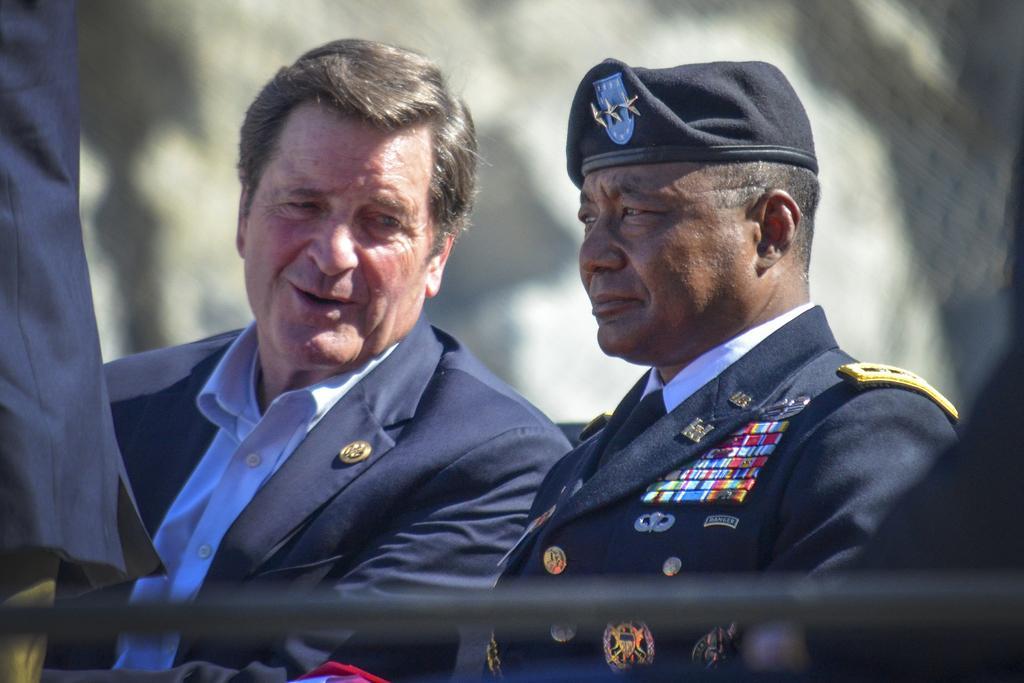In one or two sentences, can you explain what this image depicts? In this image there are two persons with the blazers ,a person with a hat , and there is blur background. 